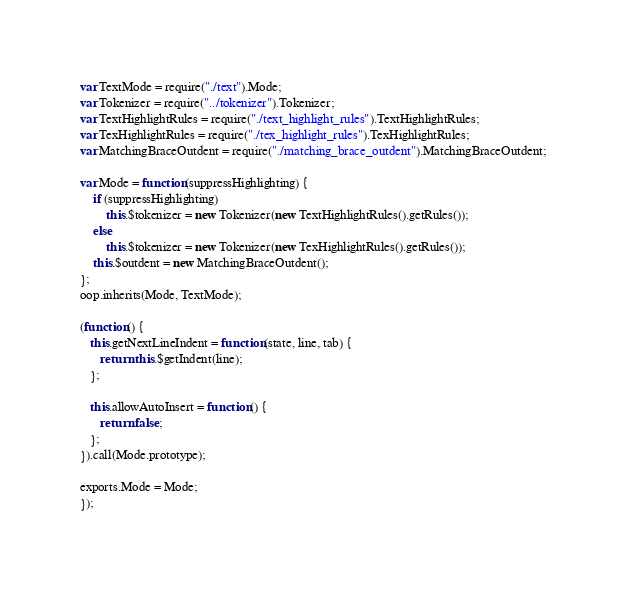Convert code to text. <code><loc_0><loc_0><loc_500><loc_500><_JavaScript_>var TextMode = require("./text").Mode;
var Tokenizer = require("../tokenizer").Tokenizer;
var TextHighlightRules = require("./text_highlight_rules").TextHighlightRules;
var TexHighlightRules = require("./tex_highlight_rules").TexHighlightRules;
var MatchingBraceOutdent = require("./matching_brace_outdent").MatchingBraceOutdent;

var Mode = function(suppressHighlighting) {
	if (suppressHighlighting)
    	this.$tokenizer = new Tokenizer(new TextHighlightRules().getRules());
	else
    	this.$tokenizer = new Tokenizer(new TexHighlightRules().getRules());
    this.$outdent = new MatchingBraceOutdent();
};
oop.inherits(Mode, TextMode);

(function() {
   this.getNextLineIndent = function(state, line, tab) {
      return this.$getIndent(line);
   };

   this.allowAutoInsert = function() {
      return false;
   };
}).call(Mode.prototype);

exports.Mode = Mode;
});</code> 